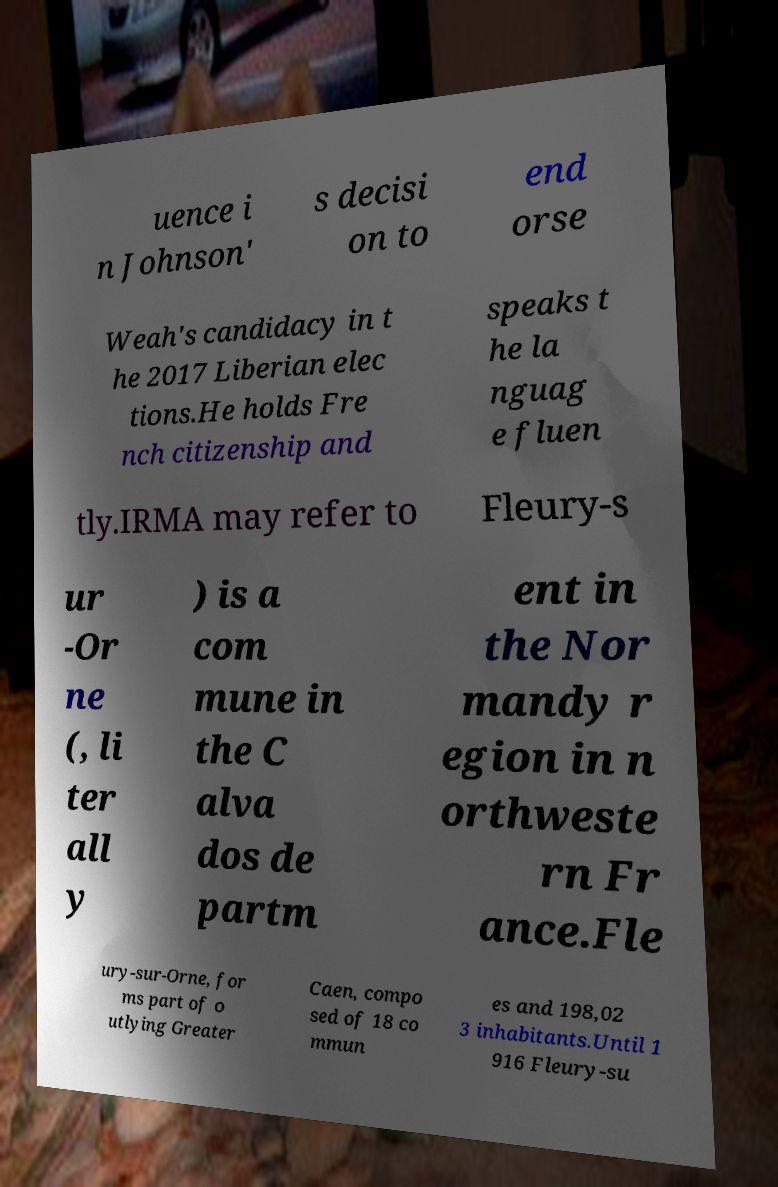Can you accurately transcribe the text from the provided image for me? uence i n Johnson' s decisi on to end orse Weah's candidacy in t he 2017 Liberian elec tions.He holds Fre nch citizenship and speaks t he la nguag e fluen tly.IRMA may refer to Fleury-s ur -Or ne (, li ter all y ) is a com mune in the C alva dos de partm ent in the Nor mandy r egion in n orthweste rn Fr ance.Fle ury-sur-Orne, for ms part of o utlying Greater Caen, compo sed of 18 co mmun es and 198,02 3 inhabitants.Until 1 916 Fleury-su 